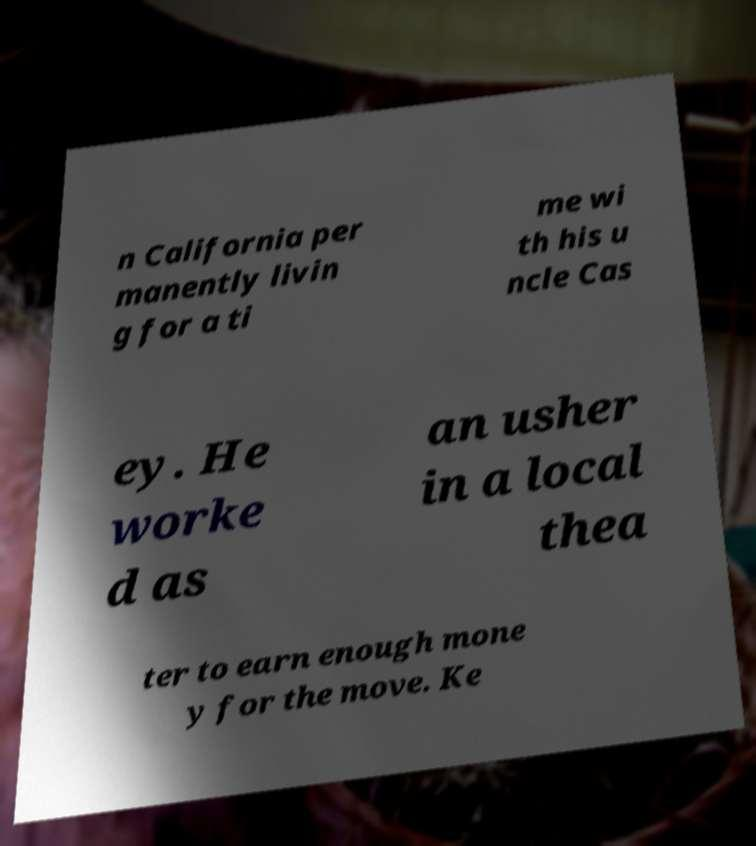For documentation purposes, I need the text within this image transcribed. Could you provide that? n California per manently livin g for a ti me wi th his u ncle Cas ey. He worke d as an usher in a local thea ter to earn enough mone y for the move. Ke 